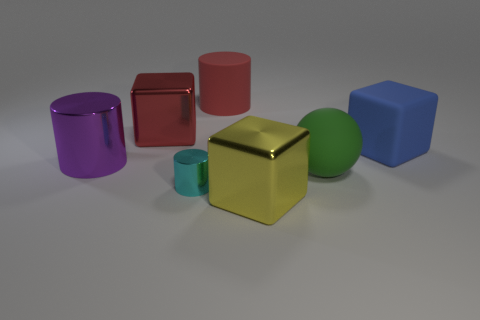What color is the other shiny object that is the same shape as the big yellow thing?
Provide a short and direct response. Red. How many things are either shiny objects behind the large blue rubber block or metal cubes that are in front of the big green matte object?
Keep it short and to the point. 2. Is the number of metallic cylinders that are on the right side of the big metallic cylinder greater than the number of large blue matte cubes that are to the left of the large red matte cylinder?
Your response must be concise. Yes. The cube to the right of the block in front of the matte thing in front of the big blue rubber object is made of what material?
Provide a short and direct response. Rubber. Do the metallic thing behind the purple metal cylinder and the small metal object in front of the purple thing have the same shape?
Make the answer very short. No. Is there a red block of the same size as the yellow metallic object?
Your answer should be compact. Yes. What number of gray things are big objects or large rubber blocks?
Ensure brevity in your answer.  0. What number of objects have the same color as the big rubber cylinder?
Provide a short and direct response. 1. Is there any other thing that has the same shape as the big green thing?
Provide a succinct answer. No. What number of cubes are either yellow shiny objects or small metallic things?
Ensure brevity in your answer.  1. 